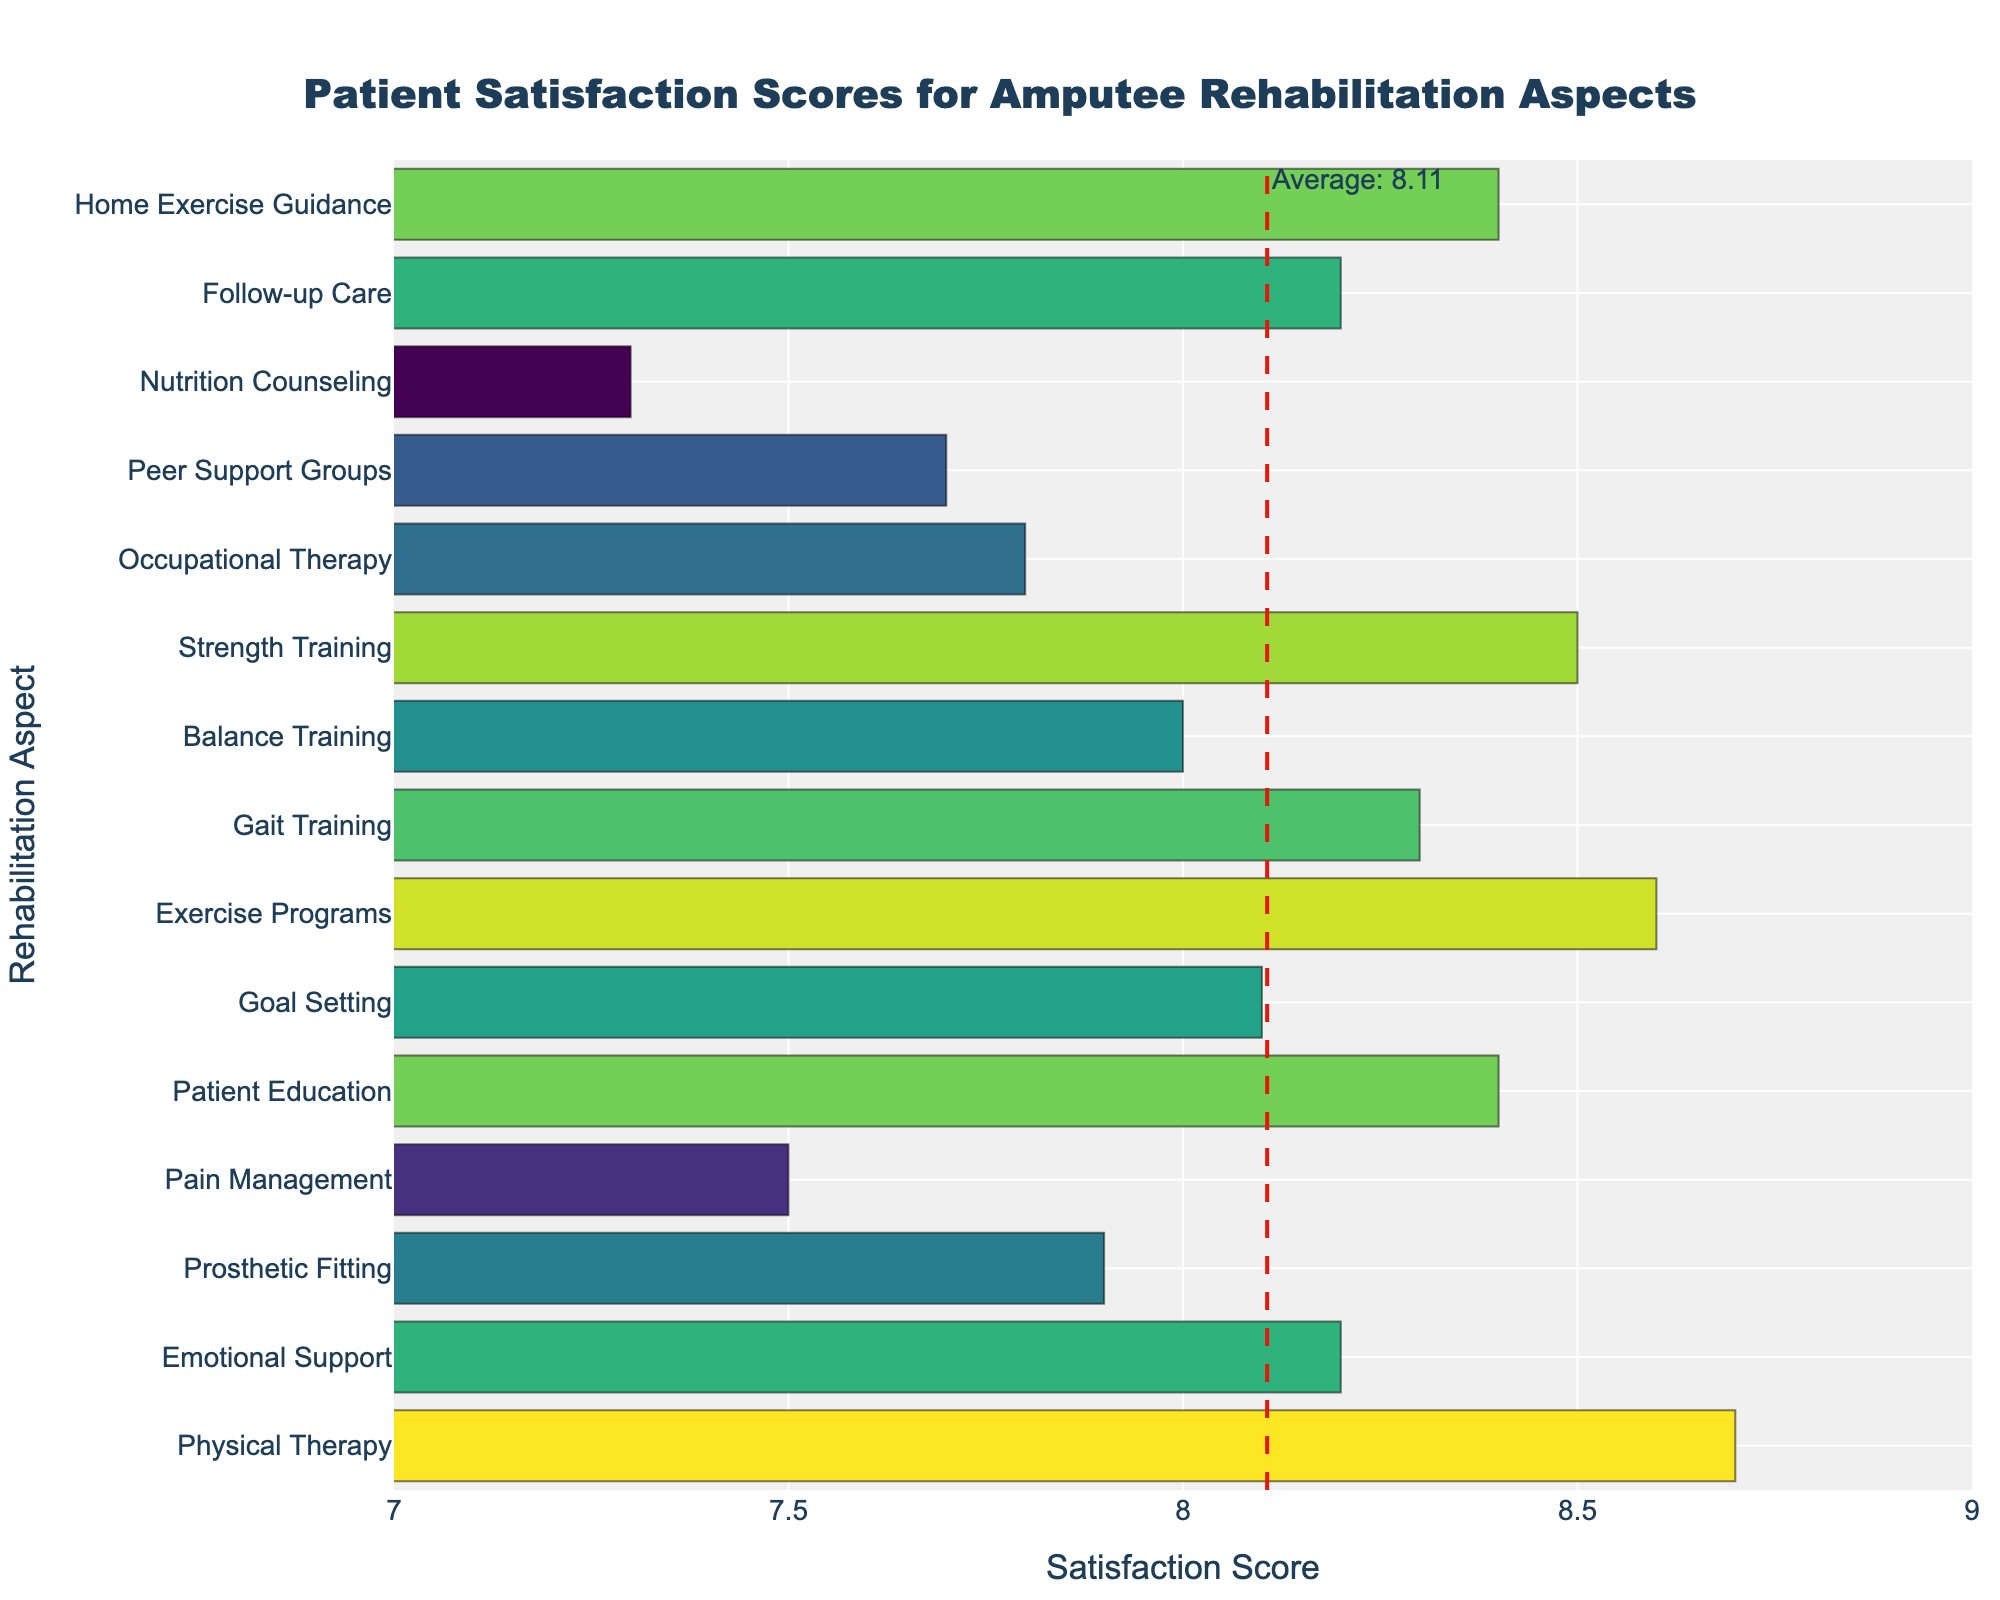What aspect of the rehabilitation program received the highest satisfaction score? The aspect with the highest satisfaction score can be identified by observing the length of the bars. The longest bar represents Physical Therapy with a score of 8.7.
Answer: Physical Therapy Which aspect has a satisfaction score closest to the average score marked by the vertical line? First, identify the position of the vertical average line on the x-axis. Then, find the bar closest to this line. Goal Setting and Follow-up Care, both with satisfaction scores of 8.2, are closest to the average.
Answer: Goal Setting and Follow-up Care How does the satisfaction score of Prosthetic Fitting compare to that of Gait Training? Compare the lengths of the bars for Prosthetic Fitting and Gait Training. Prosthetic Fitting has a score of 7.9, whereas Gait Training has a score of 8.3.
Answer: Gait Training has a higher score What is the difference in satisfaction scores between Patient Education and Nutrition Counseling? Subtract the satisfaction score of Nutrition Counseling from that of Patient Education (8.4 - 7.3 = 1.1).
Answer: 1.1 Which aspects have satisfaction scores lower than 8.0? Identify all bars with lengths indicating values less than 8.0. These aspects are Prosthetic Fitting (7.9), Pain Management (7.5), Occupational Therapy (7.8), Peer Support Groups (7.7), and Nutrition Counseling (7.3).
Answer: Prosthetic Fitting, Pain Management, Occupational Therapy, Peer Support Groups, Nutrition Counseling What is the combined satisfaction score for Emotional Support and Gait Training? Add the satisfaction scores of Emotional Support and Gait Training (8.2 + 8.3 = 16.5).
Answer: 16.5 Which aspect's satisfaction score is exactly equal to Strength Training? Identify the bar with the same length as the Strength Training bar. This aspect is the Goal Setting, both scoring 8.5.
Answer: Goal Setting How does the satisfaction score for Balance Training compare to that of Exercise Programs? Compare the bars for Balance Training (8.0) and Exercise Programs (8.6).
Answer: Exercise Programs has a higher score Which three aspects have the closest satisfaction scores to each other? Identify groups of bars with similar lengths. Gait Training (8.3), Balance Training (8.0), and Emotional Support (8.2) have closely grouped scores.
Answer: Gait Training, Balance Training, Emotional Support By what margin does Physical Therapy's satisfaction score exceed that of Peer Support Groups? Subtract the satisfaction score of Peer Support Groups from that of Physical Therapy (8.7 - 7.7 = 1.0).
Answer: 1.0 